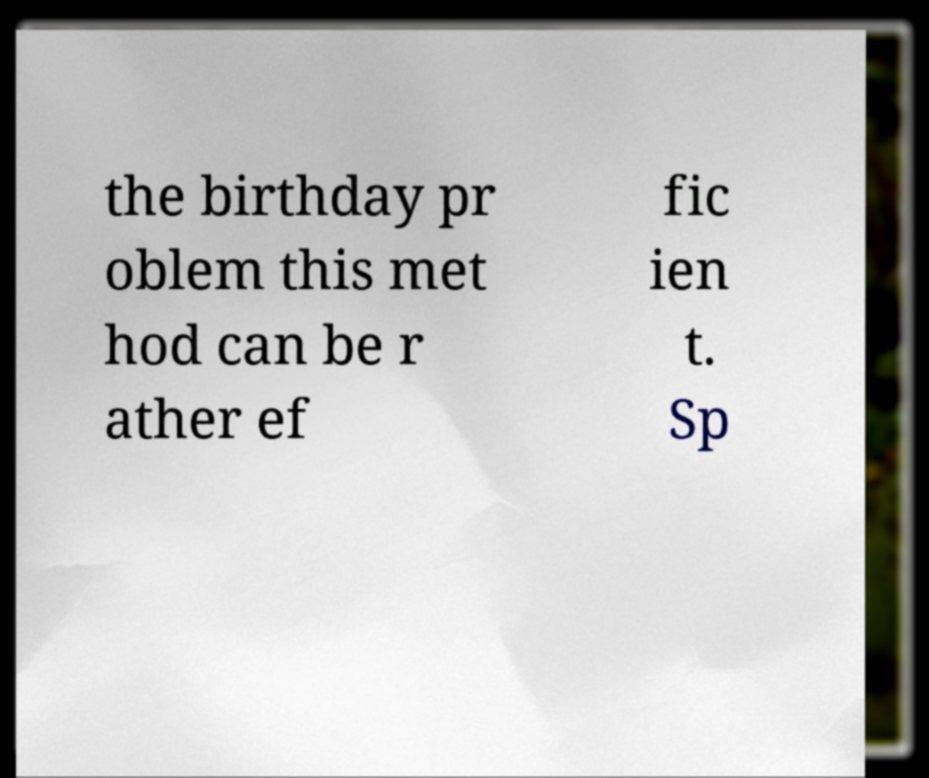Please identify and transcribe the text found in this image. the birthday pr oblem this met hod can be r ather ef fic ien t. Sp 